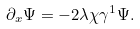<formula> <loc_0><loc_0><loc_500><loc_500>\partial _ { x } \Psi = - 2 \lambda \chi \gamma ^ { 1 } \Psi .</formula> 